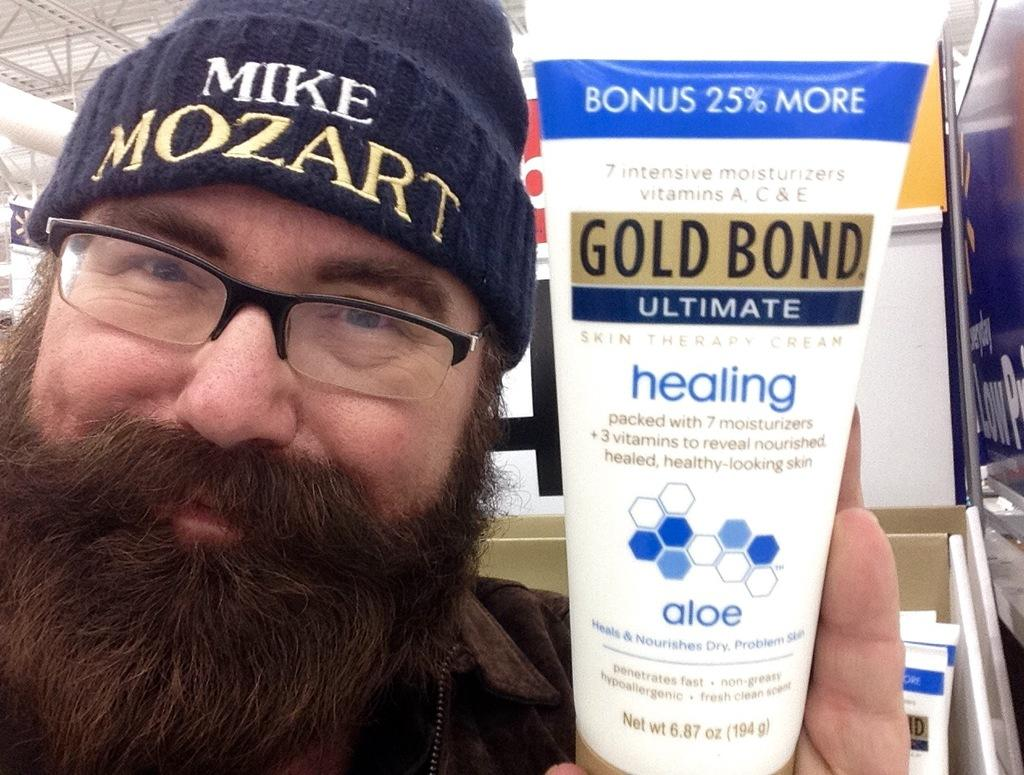<image>
Provide a brief description of the given image. A man wearing a blue hat holding a tube of Gold Bond Ultimate healing lotion. 